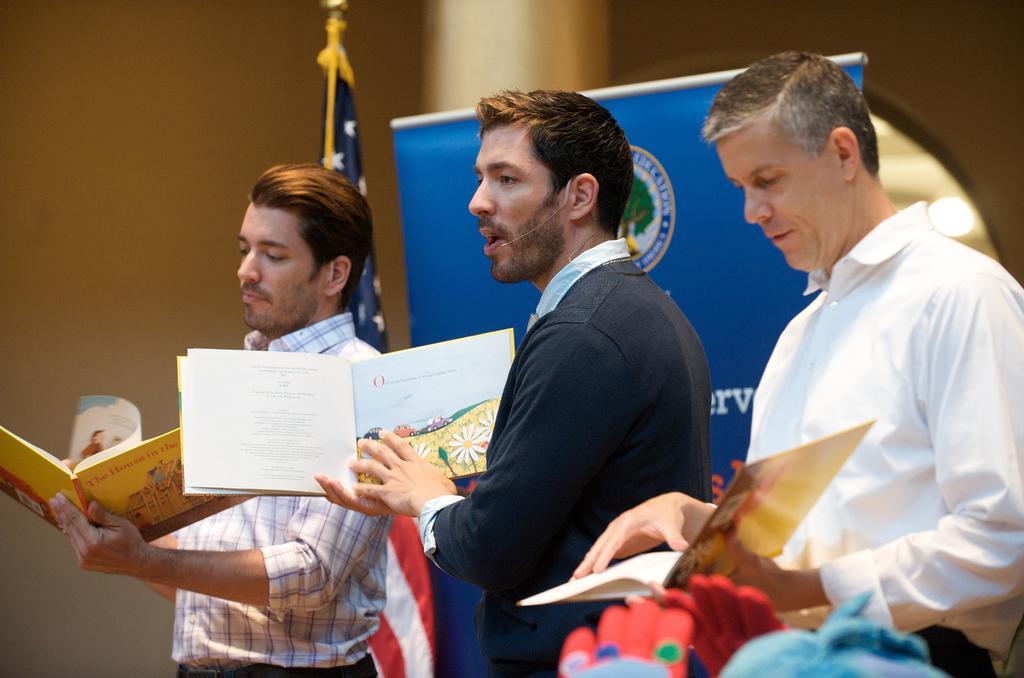Can you describe this image briefly? In this image, there are a few people holding objects. We can see a board with some text and image. We can also see a flag. In the background, we can see a pillar and the wall. We can see some objects at the bottom. 